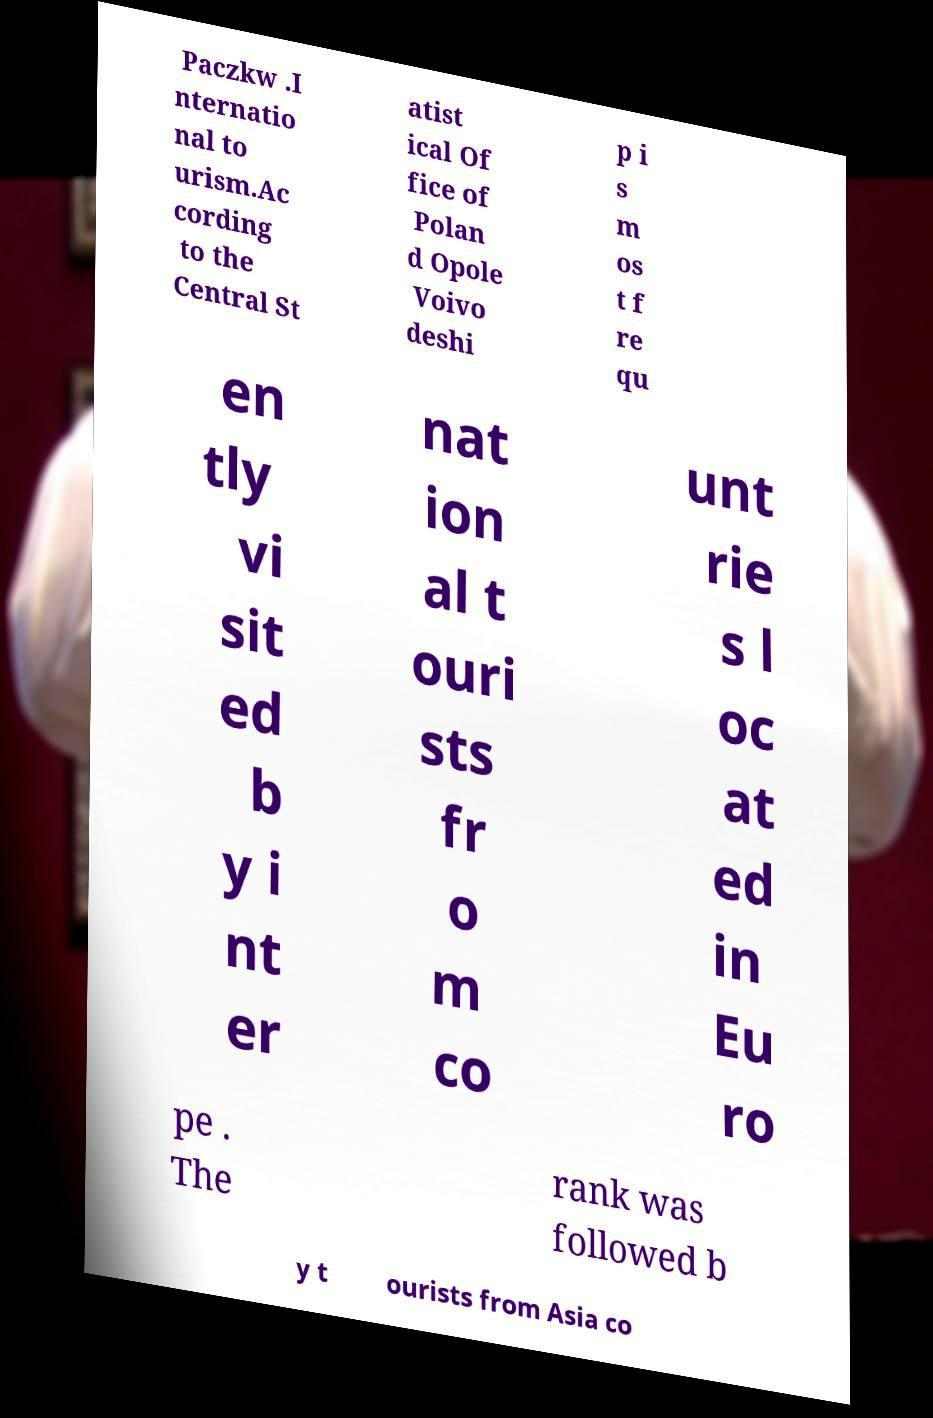Can you accurately transcribe the text from the provided image for me? Paczkw .I nternatio nal to urism.Ac cording to the Central St atist ical Of fice of Polan d Opole Voivo deshi p i s m os t f re qu en tly vi sit ed b y i nt er nat ion al t ouri sts fr o m co unt rie s l oc at ed in Eu ro pe . The rank was followed b y t ourists from Asia co 